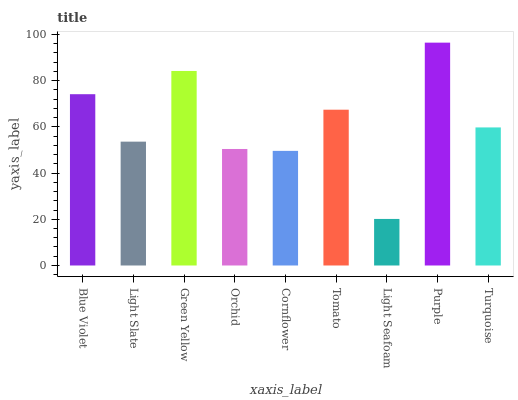Is Light Seafoam the minimum?
Answer yes or no. Yes. Is Purple the maximum?
Answer yes or no. Yes. Is Light Slate the minimum?
Answer yes or no. No. Is Light Slate the maximum?
Answer yes or no. No. Is Blue Violet greater than Light Slate?
Answer yes or no. Yes. Is Light Slate less than Blue Violet?
Answer yes or no. Yes. Is Light Slate greater than Blue Violet?
Answer yes or no. No. Is Blue Violet less than Light Slate?
Answer yes or no. No. Is Turquoise the high median?
Answer yes or no. Yes. Is Turquoise the low median?
Answer yes or no. Yes. Is Orchid the high median?
Answer yes or no. No. Is Light Slate the low median?
Answer yes or no. No. 